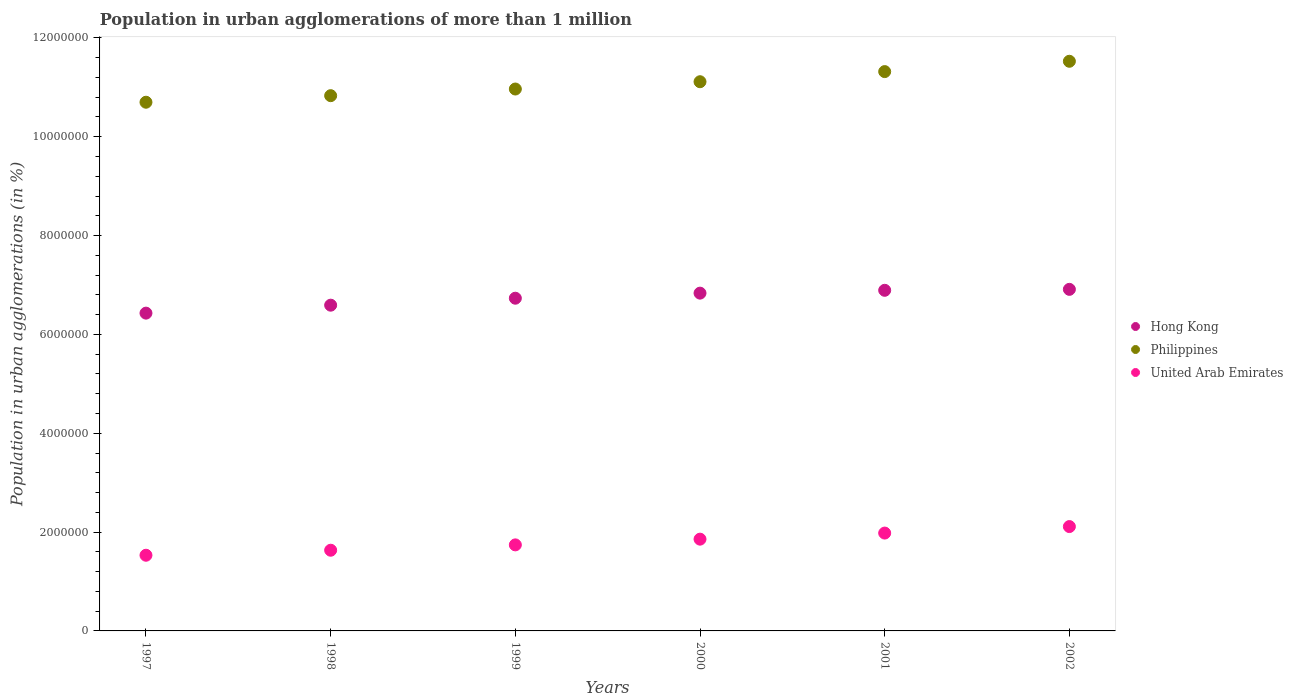Is the number of dotlines equal to the number of legend labels?
Your answer should be very brief. Yes. What is the population in urban agglomerations in Hong Kong in 2000?
Provide a short and direct response. 6.84e+06. Across all years, what is the maximum population in urban agglomerations in United Arab Emirates?
Keep it short and to the point. 2.11e+06. Across all years, what is the minimum population in urban agglomerations in United Arab Emirates?
Ensure brevity in your answer.  1.53e+06. In which year was the population in urban agglomerations in United Arab Emirates maximum?
Your answer should be very brief. 2002. In which year was the population in urban agglomerations in Hong Kong minimum?
Give a very brief answer. 1997. What is the total population in urban agglomerations in Hong Kong in the graph?
Provide a short and direct response. 4.04e+07. What is the difference between the population in urban agglomerations in United Arab Emirates in 1997 and that in 1999?
Provide a succinct answer. -2.10e+05. What is the difference between the population in urban agglomerations in United Arab Emirates in 1998 and the population in urban agglomerations in Hong Kong in 1997?
Give a very brief answer. -4.80e+06. What is the average population in urban agglomerations in Hong Kong per year?
Your answer should be very brief. 6.73e+06. In the year 1998, what is the difference between the population in urban agglomerations in Philippines and population in urban agglomerations in United Arab Emirates?
Make the answer very short. 9.20e+06. In how many years, is the population in urban agglomerations in United Arab Emirates greater than 2000000 %?
Offer a very short reply. 1. What is the ratio of the population in urban agglomerations in Philippines in 2000 to that in 2002?
Provide a succinct answer. 0.96. Is the population in urban agglomerations in United Arab Emirates in 2001 less than that in 2002?
Offer a terse response. Yes. What is the difference between the highest and the second highest population in urban agglomerations in Philippines?
Offer a terse response. 2.09e+05. What is the difference between the highest and the lowest population in urban agglomerations in Hong Kong?
Give a very brief answer. 4.81e+05. In how many years, is the population in urban agglomerations in Philippines greater than the average population in urban agglomerations in Philippines taken over all years?
Provide a succinct answer. 3. What is the difference between two consecutive major ticks on the Y-axis?
Give a very brief answer. 2.00e+06. Does the graph contain any zero values?
Offer a very short reply. No. Does the graph contain grids?
Keep it short and to the point. No. How are the legend labels stacked?
Keep it short and to the point. Vertical. What is the title of the graph?
Make the answer very short. Population in urban agglomerations of more than 1 million. What is the label or title of the Y-axis?
Make the answer very short. Population in urban agglomerations (in %). What is the Population in urban agglomerations (in %) of Hong Kong in 1997?
Your response must be concise. 6.43e+06. What is the Population in urban agglomerations (in %) in Philippines in 1997?
Make the answer very short. 1.07e+07. What is the Population in urban agglomerations (in %) of United Arab Emirates in 1997?
Your answer should be compact. 1.53e+06. What is the Population in urban agglomerations (in %) of Hong Kong in 1998?
Your answer should be compact. 6.59e+06. What is the Population in urban agglomerations (in %) of Philippines in 1998?
Ensure brevity in your answer.  1.08e+07. What is the Population in urban agglomerations (in %) of United Arab Emirates in 1998?
Make the answer very short. 1.63e+06. What is the Population in urban agglomerations (in %) of Hong Kong in 1999?
Ensure brevity in your answer.  6.73e+06. What is the Population in urban agglomerations (in %) of Philippines in 1999?
Your answer should be compact. 1.10e+07. What is the Population in urban agglomerations (in %) of United Arab Emirates in 1999?
Make the answer very short. 1.74e+06. What is the Population in urban agglomerations (in %) in Hong Kong in 2000?
Your answer should be very brief. 6.84e+06. What is the Population in urban agglomerations (in %) of Philippines in 2000?
Your answer should be very brief. 1.11e+07. What is the Population in urban agglomerations (in %) of United Arab Emirates in 2000?
Offer a terse response. 1.86e+06. What is the Population in urban agglomerations (in %) in Hong Kong in 2001?
Offer a very short reply. 6.89e+06. What is the Population in urban agglomerations (in %) of Philippines in 2001?
Provide a succinct answer. 1.13e+07. What is the Population in urban agglomerations (in %) in United Arab Emirates in 2001?
Make the answer very short. 1.98e+06. What is the Population in urban agglomerations (in %) in Hong Kong in 2002?
Keep it short and to the point. 6.91e+06. What is the Population in urban agglomerations (in %) of Philippines in 2002?
Offer a terse response. 1.15e+07. What is the Population in urban agglomerations (in %) of United Arab Emirates in 2002?
Make the answer very short. 2.11e+06. Across all years, what is the maximum Population in urban agglomerations (in %) of Hong Kong?
Your answer should be compact. 6.91e+06. Across all years, what is the maximum Population in urban agglomerations (in %) in Philippines?
Your answer should be very brief. 1.15e+07. Across all years, what is the maximum Population in urban agglomerations (in %) in United Arab Emirates?
Offer a very short reply. 2.11e+06. Across all years, what is the minimum Population in urban agglomerations (in %) in Hong Kong?
Your response must be concise. 6.43e+06. Across all years, what is the minimum Population in urban agglomerations (in %) in Philippines?
Your answer should be very brief. 1.07e+07. Across all years, what is the minimum Population in urban agglomerations (in %) in United Arab Emirates?
Offer a very short reply. 1.53e+06. What is the total Population in urban agglomerations (in %) in Hong Kong in the graph?
Your response must be concise. 4.04e+07. What is the total Population in urban agglomerations (in %) of Philippines in the graph?
Offer a terse response. 6.65e+07. What is the total Population in urban agglomerations (in %) of United Arab Emirates in the graph?
Provide a short and direct response. 1.09e+07. What is the difference between the Population in urban agglomerations (in %) in Hong Kong in 1997 and that in 1998?
Provide a short and direct response. -1.61e+05. What is the difference between the Population in urban agglomerations (in %) of Philippines in 1997 and that in 1998?
Your answer should be compact. -1.33e+05. What is the difference between the Population in urban agglomerations (in %) of United Arab Emirates in 1997 and that in 1998?
Provide a short and direct response. -1.01e+05. What is the difference between the Population in urban agglomerations (in %) in Hong Kong in 1997 and that in 1999?
Your answer should be very brief. -3.02e+05. What is the difference between the Population in urban agglomerations (in %) of Philippines in 1997 and that in 1999?
Ensure brevity in your answer.  -2.67e+05. What is the difference between the Population in urban agglomerations (in %) of United Arab Emirates in 1997 and that in 1999?
Offer a very short reply. -2.10e+05. What is the difference between the Population in urban agglomerations (in %) in Hong Kong in 1997 and that in 2000?
Ensure brevity in your answer.  -4.05e+05. What is the difference between the Population in urban agglomerations (in %) in Philippines in 1997 and that in 2000?
Your answer should be very brief. -4.15e+05. What is the difference between the Population in urban agglomerations (in %) in United Arab Emirates in 1997 and that in 2000?
Your answer should be very brief. -3.25e+05. What is the difference between the Population in urban agglomerations (in %) of Hong Kong in 1997 and that in 2001?
Provide a succinct answer. -4.62e+05. What is the difference between the Population in urban agglomerations (in %) in Philippines in 1997 and that in 2001?
Provide a short and direct response. -6.20e+05. What is the difference between the Population in urban agglomerations (in %) of United Arab Emirates in 1997 and that in 2001?
Keep it short and to the point. -4.49e+05. What is the difference between the Population in urban agglomerations (in %) in Hong Kong in 1997 and that in 2002?
Ensure brevity in your answer.  -4.81e+05. What is the difference between the Population in urban agglomerations (in %) of Philippines in 1997 and that in 2002?
Your answer should be compact. -8.29e+05. What is the difference between the Population in urban agglomerations (in %) in United Arab Emirates in 1997 and that in 2002?
Provide a succinct answer. -5.80e+05. What is the difference between the Population in urban agglomerations (in %) of Hong Kong in 1998 and that in 1999?
Your response must be concise. -1.41e+05. What is the difference between the Population in urban agglomerations (in %) of Philippines in 1998 and that in 1999?
Provide a short and direct response. -1.35e+05. What is the difference between the Population in urban agglomerations (in %) of United Arab Emirates in 1998 and that in 1999?
Give a very brief answer. -1.08e+05. What is the difference between the Population in urban agglomerations (in %) of Hong Kong in 1998 and that in 2000?
Your response must be concise. -2.44e+05. What is the difference between the Population in urban agglomerations (in %) of Philippines in 1998 and that in 2000?
Offer a very short reply. -2.82e+05. What is the difference between the Population in urban agglomerations (in %) of United Arab Emirates in 1998 and that in 2000?
Provide a succinct answer. -2.24e+05. What is the difference between the Population in urban agglomerations (in %) in Hong Kong in 1998 and that in 2001?
Offer a terse response. -3.01e+05. What is the difference between the Population in urban agglomerations (in %) in Philippines in 1998 and that in 2001?
Your answer should be very brief. -4.87e+05. What is the difference between the Population in urban agglomerations (in %) in United Arab Emirates in 1998 and that in 2001?
Give a very brief answer. -3.47e+05. What is the difference between the Population in urban agglomerations (in %) of Hong Kong in 1998 and that in 2002?
Your answer should be very brief. -3.20e+05. What is the difference between the Population in urban agglomerations (in %) in Philippines in 1998 and that in 2002?
Provide a succinct answer. -6.96e+05. What is the difference between the Population in urban agglomerations (in %) of United Arab Emirates in 1998 and that in 2002?
Provide a succinct answer. -4.79e+05. What is the difference between the Population in urban agglomerations (in %) in Hong Kong in 1999 and that in 2000?
Make the answer very short. -1.03e+05. What is the difference between the Population in urban agglomerations (in %) in Philippines in 1999 and that in 2000?
Your answer should be very brief. -1.48e+05. What is the difference between the Population in urban agglomerations (in %) in United Arab Emirates in 1999 and that in 2000?
Your answer should be very brief. -1.16e+05. What is the difference between the Population in urban agglomerations (in %) in Hong Kong in 1999 and that in 2001?
Give a very brief answer. -1.60e+05. What is the difference between the Population in urban agglomerations (in %) in Philippines in 1999 and that in 2001?
Provide a short and direct response. -3.53e+05. What is the difference between the Population in urban agglomerations (in %) of United Arab Emirates in 1999 and that in 2001?
Ensure brevity in your answer.  -2.39e+05. What is the difference between the Population in urban agglomerations (in %) of Hong Kong in 1999 and that in 2002?
Make the answer very short. -1.79e+05. What is the difference between the Population in urban agglomerations (in %) of Philippines in 1999 and that in 2002?
Offer a terse response. -5.62e+05. What is the difference between the Population in urban agglomerations (in %) in United Arab Emirates in 1999 and that in 2002?
Provide a succinct answer. -3.70e+05. What is the difference between the Population in urban agglomerations (in %) in Hong Kong in 2000 and that in 2001?
Your response must be concise. -5.75e+04. What is the difference between the Population in urban agglomerations (in %) of Philippines in 2000 and that in 2001?
Provide a succinct answer. -2.05e+05. What is the difference between the Population in urban agglomerations (in %) of United Arab Emirates in 2000 and that in 2001?
Your answer should be compact. -1.23e+05. What is the difference between the Population in urban agglomerations (in %) in Hong Kong in 2000 and that in 2002?
Ensure brevity in your answer.  -7.68e+04. What is the difference between the Population in urban agglomerations (in %) of Philippines in 2000 and that in 2002?
Provide a short and direct response. -4.14e+05. What is the difference between the Population in urban agglomerations (in %) in United Arab Emirates in 2000 and that in 2002?
Your answer should be very brief. -2.55e+05. What is the difference between the Population in urban agglomerations (in %) in Hong Kong in 2001 and that in 2002?
Provide a succinct answer. -1.93e+04. What is the difference between the Population in urban agglomerations (in %) of Philippines in 2001 and that in 2002?
Offer a terse response. -2.09e+05. What is the difference between the Population in urban agglomerations (in %) of United Arab Emirates in 2001 and that in 2002?
Your answer should be compact. -1.32e+05. What is the difference between the Population in urban agglomerations (in %) of Hong Kong in 1997 and the Population in urban agglomerations (in %) of Philippines in 1998?
Your answer should be very brief. -4.40e+06. What is the difference between the Population in urban agglomerations (in %) in Hong Kong in 1997 and the Population in urban agglomerations (in %) in United Arab Emirates in 1998?
Give a very brief answer. 4.80e+06. What is the difference between the Population in urban agglomerations (in %) of Philippines in 1997 and the Population in urban agglomerations (in %) of United Arab Emirates in 1998?
Ensure brevity in your answer.  9.07e+06. What is the difference between the Population in urban agglomerations (in %) in Hong Kong in 1997 and the Population in urban agglomerations (in %) in Philippines in 1999?
Provide a short and direct response. -4.54e+06. What is the difference between the Population in urban agglomerations (in %) of Hong Kong in 1997 and the Population in urban agglomerations (in %) of United Arab Emirates in 1999?
Keep it short and to the point. 4.69e+06. What is the difference between the Population in urban agglomerations (in %) of Philippines in 1997 and the Population in urban agglomerations (in %) of United Arab Emirates in 1999?
Your answer should be very brief. 8.96e+06. What is the difference between the Population in urban agglomerations (in %) of Hong Kong in 1997 and the Population in urban agglomerations (in %) of Philippines in 2000?
Your answer should be very brief. -4.68e+06. What is the difference between the Population in urban agglomerations (in %) of Hong Kong in 1997 and the Population in urban agglomerations (in %) of United Arab Emirates in 2000?
Offer a very short reply. 4.57e+06. What is the difference between the Population in urban agglomerations (in %) of Philippines in 1997 and the Population in urban agglomerations (in %) of United Arab Emirates in 2000?
Make the answer very short. 8.84e+06. What is the difference between the Population in urban agglomerations (in %) in Hong Kong in 1997 and the Population in urban agglomerations (in %) in Philippines in 2001?
Offer a very short reply. -4.89e+06. What is the difference between the Population in urban agglomerations (in %) in Hong Kong in 1997 and the Population in urban agglomerations (in %) in United Arab Emirates in 2001?
Offer a terse response. 4.45e+06. What is the difference between the Population in urban agglomerations (in %) of Philippines in 1997 and the Population in urban agglomerations (in %) of United Arab Emirates in 2001?
Offer a very short reply. 8.72e+06. What is the difference between the Population in urban agglomerations (in %) of Hong Kong in 1997 and the Population in urban agglomerations (in %) of Philippines in 2002?
Give a very brief answer. -5.10e+06. What is the difference between the Population in urban agglomerations (in %) of Hong Kong in 1997 and the Population in urban agglomerations (in %) of United Arab Emirates in 2002?
Your answer should be compact. 4.32e+06. What is the difference between the Population in urban agglomerations (in %) of Philippines in 1997 and the Population in urban agglomerations (in %) of United Arab Emirates in 2002?
Keep it short and to the point. 8.59e+06. What is the difference between the Population in urban agglomerations (in %) of Hong Kong in 1998 and the Population in urban agglomerations (in %) of Philippines in 1999?
Provide a succinct answer. -4.37e+06. What is the difference between the Population in urban agglomerations (in %) of Hong Kong in 1998 and the Population in urban agglomerations (in %) of United Arab Emirates in 1999?
Give a very brief answer. 4.85e+06. What is the difference between the Population in urban agglomerations (in %) in Philippines in 1998 and the Population in urban agglomerations (in %) in United Arab Emirates in 1999?
Provide a succinct answer. 9.09e+06. What is the difference between the Population in urban agglomerations (in %) of Hong Kong in 1998 and the Population in urban agglomerations (in %) of Philippines in 2000?
Make the answer very short. -4.52e+06. What is the difference between the Population in urban agglomerations (in %) of Hong Kong in 1998 and the Population in urban agglomerations (in %) of United Arab Emirates in 2000?
Keep it short and to the point. 4.73e+06. What is the difference between the Population in urban agglomerations (in %) in Philippines in 1998 and the Population in urban agglomerations (in %) in United Arab Emirates in 2000?
Your answer should be very brief. 8.97e+06. What is the difference between the Population in urban agglomerations (in %) of Hong Kong in 1998 and the Population in urban agglomerations (in %) of Philippines in 2001?
Offer a terse response. -4.73e+06. What is the difference between the Population in urban agglomerations (in %) in Hong Kong in 1998 and the Population in urban agglomerations (in %) in United Arab Emirates in 2001?
Offer a terse response. 4.61e+06. What is the difference between the Population in urban agglomerations (in %) in Philippines in 1998 and the Population in urban agglomerations (in %) in United Arab Emirates in 2001?
Give a very brief answer. 8.85e+06. What is the difference between the Population in urban agglomerations (in %) in Hong Kong in 1998 and the Population in urban agglomerations (in %) in Philippines in 2002?
Ensure brevity in your answer.  -4.94e+06. What is the difference between the Population in urban agglomerations (in %) of Hong Kong in 1998 and the Population in urban agglomerations (in %) of United Arab Emirates in 2002?
Provide a short and direct response. 4.48e+06. What is the difference between the Population in urban agglomerations (in %) in Philippines in 1998 and the Population in urban agglomerations (in %) in United Arab Emirates in 2002?
Provide a succinct answer. 8.72e+06. What is the difference between the Population in urban agglomerations (in %) of Hong Kong in 1999 and the Population in urban agglomerations (in %) of Philippines in 2000?
Provide a succinct answer. -4.38e+06. What is the difference between the Population in urban agglomerations (in %) in Hong Kong in 1999 and the Population in urban agglomerations (in %) in United Arab Emirates in 2000?
Offer a terse response. 4.88e+06. What is the difference between the Population in urban agglomerations (in %) in Philippines in 1999 and the Population in urban agglomerations (in %) in United Arab Emirates in 2000?
Keep it short and to the point. 9.11e+06. What is the difference between the Population in urban agglomerations (in %) of Hong Kong in 1999 and the Population in urban agglomerations (in %) of Philippines in 2001?
Offer a terse response. -4.59e+06. What is the difference between the Population in urban agglomerations (in %) of Hong Kong in 1999 and the Population in urban agglomerations (in %) of United Arab Emirates in 2001?
Give a very brief answer. 4.75e+06. What is the difference between the Population in urban agglomerations (in %) in Philippines in 1999 and the Population in urban agglomerations (in %) in United Arab Emirates in 2001?
Your answer should be compact. 8.99e+06. What is the difference between the Population in urban agglomerations (in %) in Hong Kong in 1999 and the Population in urban agglomerations (in %) in Philippines in 2002?
Offer a very short reply. -4.79e+06. What is the difference between the Population in urban agglomerations (in %) in Hong Kong in 1999 and the Population in urban agglomerations (in %) in United Arab Emirates in 2002?
Your response must be concise. 4.62e+06. What is the difference between the Population in urban agglomerations (in %) of Philippines in 1999 and the Population in urban agglomerations (in %) of United Arab Emirates in 2002?
Provide a succinct answer. 8.85e+06. What is the difference between the Population in urban agglomerations (in %) of Hong Kong in 2000 and the Population in urban agglomerations (in %) of Philippines in 2001?
Your answer should be compact. -4.48e+06. What is the difference between the Population in urban agglomerations (in %) in Hong Kong in 2000 and the Population in urban agglomerations (in %) in United Arab Emirates in 2001?
Your response must be concise. 4.86e+06. What is the difference between the Population in urban agglomerations (in %) of Philippines in 2000 and the Population in urban agglomerations (in %) of United Arab Emirates in 2001?
Offer a very short reply. 9.13e+06. What is the difference between the Population in urban agglomerations (in %) in Hong Kong in 2000 and the Population in urban agglomerations (in %) in Philippines in 2002?
Provide a succinct answer. -4.69e+06. What is the difference between the Population in urban agglomerations (in %) of Hong Kong in 2000 and the Population in urban agglomerations (in %) of United Arab Emirates in 2002?
Your answer should be compact. 4.72e+06. What is the difference between the Population in urban agglomerations (in %) of Philippines in 2000 and the Population in urban agglomerations (in %) of United Arab Emirates in 2002?
Your answer should be compact. 9.00e+06. What is the difference between the Population in urban agglomerations (in %) in Hong Kong in 2001 and the Population in urban agglomerations (in %) in Philippines in 2002?
Give a very brief answer. -4.63e+06. What is the difference between the Population in urban agglomerations (in %) of Hong Kong in 2001 and the Population in urban agglomerations (in %) of United Arab Emirates in 2002?
Make the answer very short. 4.78e+06. What is the difference between the Population in urban agglomerations (in %) in Philippines in 2001 and the Population in urban agglomerations (in %) in United Arab Emirates in 2002?
Offer a very short reply. 9.21e+06. What is the average Population in urban agglomerations (in %) of Hong Kong per year?
Your answer should be very brief. 6.73e+06. What is the average Population in urban agglomerations (in %) in Philippines per year?
Offer a terse response. 1.11e+07. What is the average Population in urban agglomerations (in %) of United Arab Emirates per year?
Give a very brief answer. 1.81e+06. In the year 1997, what is the difference between the Population in urban agglomerations (in %) in Hong Kong and Population in urban agglomerations (in %) in Philippines?
Offer a very short reply. -4.27e+06. In the year 1997, what is the difference between the Population in urban agglomerations (in %) of Hong Kong and Population in urban agglomerations (in %) of United Arab Emirates?
Your answer should be compact. 4.90e+06. In the year 1997, what is the difference between the Population in urban agglomerations (in %) of Philippines and Population in urban agglomerations (in %) of United Arab Emirates?
Provide a succinct answer. 9.17e+06. In the year 1998, what is the difference between the Population in urban agglomerations (in %) in Hong Kong and Population in urban agglomerations (in %) in Philippines?
Offer a very short reply. -4.24e+06. In the year 1998, what is the difference between the Population in urban agglomerations (in %) in Hong Kong and Population in urban agglomerations (in %) in United Arab Emirates?
Provide a succinct answer. 4.96e+06. In the year 1998, what is the difference between the Population in urban agglomerations (in %) of Philippines and Population in urban agglomerations (in %) of United Arab Emirates?
Your answer should be very brief. 9.20e+06. In the year 1999, what is the difference between the Population in urban agglomerations (in %) of Hong Kong and Population in urban agglomerations (in %) of Philippines?
Provide a short and direct response. -4.23e+06. In the year 1999, what is the difference between the Population in urban agglomerations (in %) of Hong Kong and Population in urban agglomerations (in %) of United Arab Emirates?
Your answer should be very brief. 4.99e+06. In the year 1999, what is the difference between the Population in urban agglomerations (in %) in Philippines and Population in urban agglomerations (in %) in United Arab Emirates?
Offer a very short reply. 9.22e+06. In the year 2000, what is the difference between the Population in urban agglomerations (in %) in Hong Kong and Population in urban agglomerations (in %) in Philippines?
Keep it short and to the point. -4.28e+06. In the year 2000, what is the difference between the Population in urban agglomerations (in %) of Hong Kong and Population in urban agglomerations (in %) of United Arab Emirates?
Make the answer very short. 4.98e+06. In the year 2000, what is the difference between the Population in urban agglomerations (in %) in Philippines and Population in urban agglomerations (in %) in United Arab Emirates?
Provide a succinct answer. 9.26e+06. In the year 2001, what is the difference between the Population in urban agglomerations (in %) in Hong Kong and Population in urban agglomerations (in %) in Philippines?
Provide a succinct answer. -4.43e+06. In the year 2001, what is the difference between the Population in urban agglomerations (in %) in Hong Kong and Population in urban agglomerations (in %) in United Arab Emirates?
Give a very brief answer. 4.91e+06. In the year 2001, what is the difference between the Population in urban agglomerations (in %) in Philippines and Population in urban agglomerations (in %) in United Arab Emirates?
Provide a succinct answer. 9.34e+06. In the year 2002, what is the difference between the Population in urban agglomerations (in %) of Hong Kong and Population in urban agglomerations (in %) of Philippines?
Your answer should be compact. -4.62e+06. In the year 2002, what is the difference between the Population in urban agglomerations (in %) of Hong Kong and Population in urban agglomerations (in %) of United Arab Emirates?
Offer a very short reply. 4.80e+06. In the year 2002, what is the difference between the Population in urban agglomerations (in %) of Philippines and Population in urban agglomerations (in %) of United Arab Emirates?
Provide a short and direct response. 9.42e+06. What is the ratio of the Population in urban agglomerations (in %) in Hong Kong in 1997 to that in 1998?
Give a very brief answer. 0.98. What is the ratio of the Population in urban agglomerations (in %) of Philippines in 1997 to that in 1998?
Your answer should be very brief. 0.99. What is the ratio of the Population in urban agglomerations (in %) of United Arab Emirates in 1997 to that in 1998?
Your answer should be very brief. 0.94. What is the ratio of the Population in urban agglomerations (in %) of Hong Kong in 1997 to that in 1999?
Your answer should be very brief. 0.96. What is the ratio of the Population in urban agglomerations (in %) of Philippines in 1997 to that in 1999?
Your answer should be compact. 0.98. What is the ratio of the Population in urban agglomerations (in %) of United Arab Emirates in 1997 to that in 1999?
Ensure brevity in your answer.  0.88. What is the ratio of the Population in urban agglomerations (in %) of Hong Kong in 1997 to that in 2000?
Make the answer very short. 0.94. What is the ratio of the Population in urban agglomerations (in %) of Philippines in 1997 to that in 2000?
Your response must be concise. 0.96. What is the ratio of the Population in urban agglomerations (in %) of United Arab Emirates in 1997 to that in 2000?
Ensure brevity in your answer.  0.82. What is the ratio of the Population in urban agglomerations (in %) of Hong Kong in 1997 to that in 2001?
Make the answer very short. 0.93. What is the ratio of the Population in urban agglomerations (in %) of Philippines in 1997 to that in 2001?
Your response must be concise. 0.95. What is the ratio of the Population in urban agglomerations (in %) of United Arab Emirates in 1997 to that in 2001?
Give a very brief answer. 0.77. What is the ratio of the Population in urban agglomerations (in %) in Hong Kong in 1997 to that in 2002?
Your answer should be compact. 0.93. What is the ratio of the Population in urban agglomerations (in %) in Philippines in 1997 to that in 2002?
Provide a short and direct response. 0.93. What is the ratio of the Population in urban agglomerations (in %) in United Arab Emirates in 1997 to that in 2002?
Provide a succinct answer. 0.73. What is the ratio of the Population in urban agglomerations (in %) in Hong Kong in 1998 to that in 1999?
Offer a very short reply. 0.98. What is the ratio of the Population in urban agglomerations (in %) of Philippines in 1998 to that in 1999?
Ensure brevity in your answer.  0.99. What is the ratio of the Population in urban agglomerations (in %) of United Arab Emirates in 1998 to that in 1999?
Offer a terse response. 0.94. What is the ratio of the Population in urban agglomerations (in %) in Hong Kong in 1998 to that in 2000?
Your response must be concise. 0.96. What is the ratio of the Population in urban agglomerations (in %) of Philippines in 1998 to that in 2000?
Offer a terse response. 0.97. What is the ratio of the Population in urban agglomerations (in %) in United Arab Emirates in 1998 to that in 2000?
Keep it short and to the point. 0.88. What is the ratio of the Population in urban agglomerations (in %) in Hong Kong in 1998 to that in 2001?
Your answer should be very brief. 0.96. What is the ratio of the Population in urban agglomerations (in %) in United Arab Emirates in 1998 to that in 2001?
Give a very brief answer. 0.82. What is the ratio of the Population in urban agglomerations (in %) in Hong Kong in 1998 to that in 2002?
Your answer should be compact. 0.95. What is the ratio of the Population in urban agglomerations (in %) of Philippines in 1998 to that in 2002?
Give a very brief answer. 0.94. What is the ratio of the Population in urban agglomerations (in %) of United Arab Emirates in 1998 to that in 2002?
Ensure brevity in your answer.  0.77. What is the ratio of the Population in urban agglomerations (in %) in Hong Kong in 1999 to that in 2000?
Keep it short and to the point. 0.98. What is the ratio of the Population in urban agglomerations (in %) of Philippines in 1999 to that in 2000?
Your response must be concise. 0.99. What is the ratio of the Population in urban agglomerations (in %) of United Arab Emirates in 1999 to that in 2000?
Offer a very short reply. 0.94. What is the ratio of the Population in urban agglomerations (in %) of Hong Kong in 1999 to that in 2001?
Offer a very short reply. 0.98. What is the ratio of the Population in urban agglomerations (in %) of Philippines in 1999 to that in 2001?
Make the answer very short. 0.97. What is the ratio of the Population in urban agglomerations (in %) in United Arab Emirates in 1999 to that in 2001?
Your answer should be very brief. 0.88. What is the ratio of the Population in urban agglomerations (in %) of Hong Kong in 1999 to that in 2002?
Offer a very short reply. 0.97. What is the ratio of the Population in urban agglomerations (in %) of Philippines in 1999 to that in 2002?
Offer a terse response. 0.95. What is the ratio of the Population in urban agglomerations (in %) in United Arab Emirates in 1999 to that in 2002?
Your answer should be compact. 0.82. What is the ratio of the Population in urban agglomerations (in %) in Hong Kong in 2000 to that in 2001?
Make the answer very short. 0.99. What is the ratio of the Population in urban agglomerations (in %) of Philippines in 2000 to that in 2001?
Your answer should be compact. 0.98. What is the ratio of the Population in urban agglomerations (in %) in United Arab Emirates in 2000 to that in 2001?
Your answer should be very brief. 0.94. What is the ratio of the Population in urban agglomerations (in %) in Hong Kong in 2000 to that in 2002?
Provide a succinct answer. 0.99. What is the ratio of the Population in urban agglomerations (in %) of Philippines in 2000 to that in 2002?
Offer a terse response. 0.96. What is the ratio of the Population in urban agglomerations (in %) in United Arab Emirates in 2000 to that in 2002?
Keep it short and to the point. 0.88. What is the ratio of the Population in urban agglomerations (in %) of Philippines in 2001 to that in 2002?
Provide a succinct answer. 0.98. What is the ratio of the Population in urban agglomerations (in %) of United Arab Emirates in 2001 to that in 2002?
Provide a succinct answer. 0.94. What is the difference between the highest and the second highest Population in urban agglomerations (in %) in Hong Kong?
Ensure brevity in your answer.  1.93e+04. What is the difference between the highest and the second highest Population in urban agglomerations (in %) in Philippines?
Provide a succinct answer. 2.09e+05. What is the difference between the highest and the second highest Population in urban agglomerations (in %) of United Arab Emirates?
Provide a succinct answer. 1.32e+05. What is the difference between the highest and the lowest Population in urban agglomerations (in %) in Hong Kong?
Make the answer very short. 4.81e+05. What is the difference between the highest and the lowest Population in urban agglomerations (in %) in Philippines?
Provide a short and direct response. 8.29e+05. What is the difference between the highest and the lowest Population in urban agglomerations (in %) in United Arab Emirates?
Offer a very short reply. 5.80e+05. 